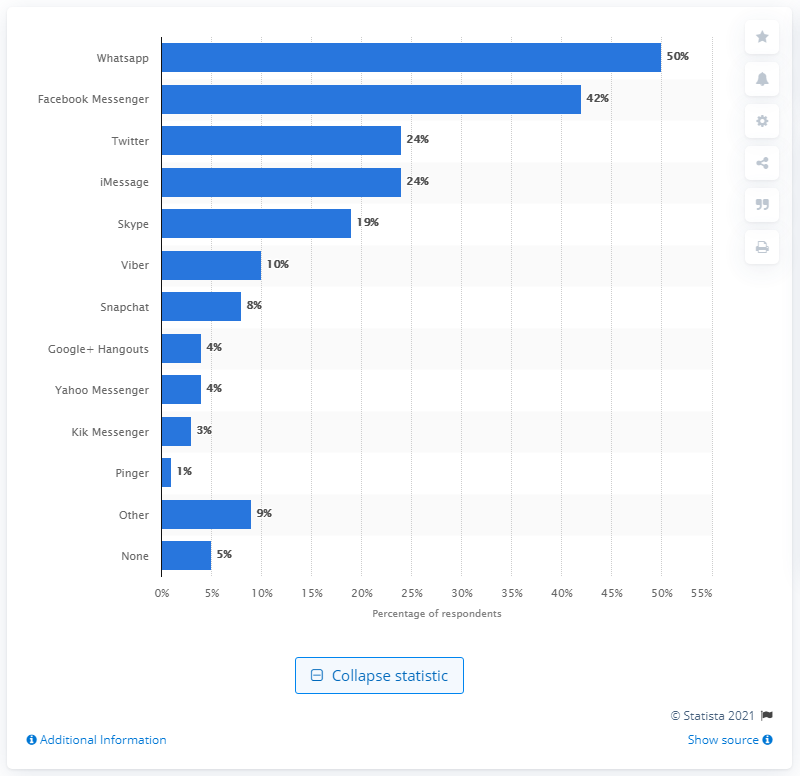Outline some significant characteristics in this image. Facebook Messenger is the second most popular instant messaging service used in the United Kingdom. WhatsApp is more popular than Snapchat, as evidenced by this statistical data. Whatsapp is the most widely used instant messaging service in the United Kingdom. 